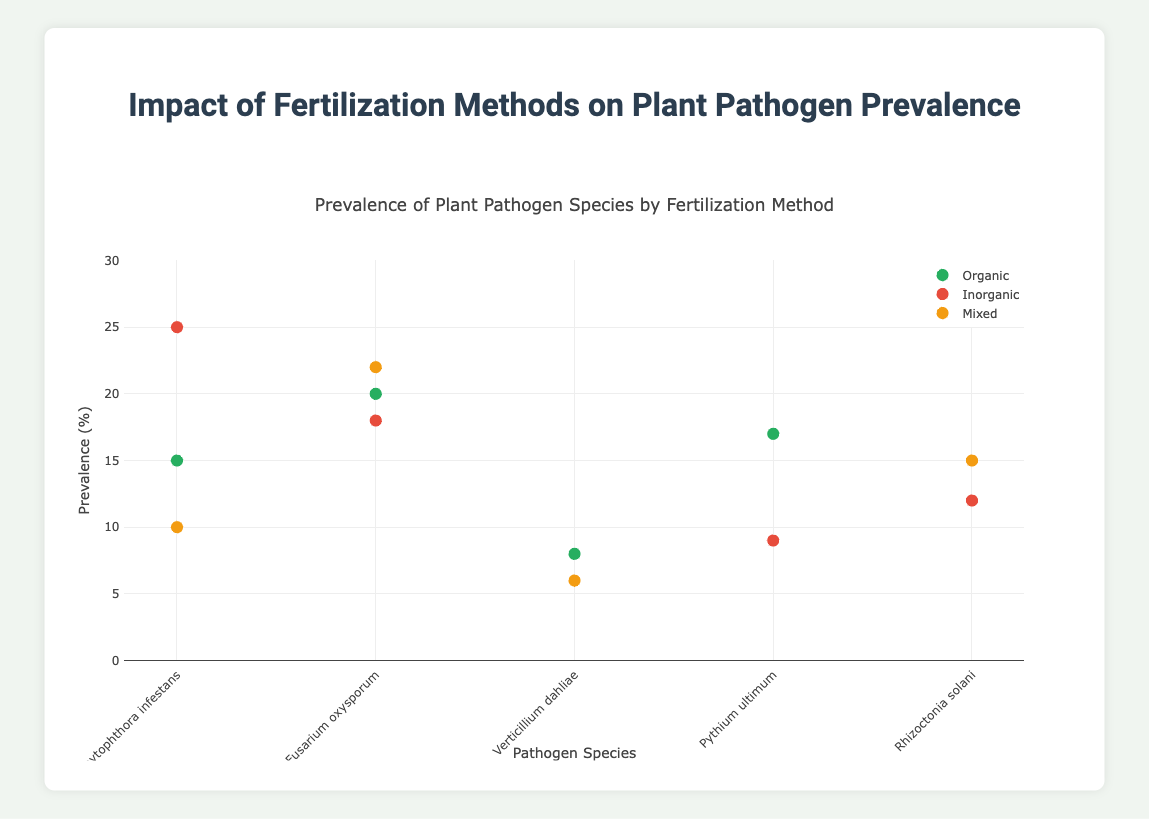What is the title of the plot? The title is located at the top of the plot and reads "Prevalence of Plant Pathogen Species by Fertilization Method"
Answer: Prevalence of Plant Pathogen Species by Fertilization Method How many fertilization methods are compared in this scatter plot? The legend on the right side of the plot shows three distinct color-coded categories representing different fertilization methods: Organic (green), Inorganic (red), and Mixed (yellow)
Answer: Three Which fertilization method has the highest prevalence for Phytophthora infestans? By looking at the markers corresponding to Phytophthora infestans on the x-axis, the highest prevalence value is associated with the Inorganic method at 25%
Answer: Inorganic What is the prevalence of Pythium ultimum in fields with organic fertilization? Locate the point corresponding to Pythium ultimum on the x-axis and check its y-axis value for the Organic category. The prevalence is 17%
Answer: 17% Which pathogen species has the lowest prevalence in the dataset? Identify the markers with the lowest y-axis values and check their corresponding pathogen species. Verticillium dahliae has a prevalence of 6% in Mixed fertilization fields, which is the lowest
Answer: Verticillium dahliae For which pathogen species do different fertilization methods result in the same or similar prevalence values? Compare the y-values for each pathogen species across different fertilization methods. Rhizoctonia solani has similar prevalence values (12% in Inorganic, 15% in Mixed)
Answer: Rhizoctonia solani Which fertilization method shows the greatest variation in pathogen prevalence? By observing the spread of data points for each fertilization method, Inorganic has points ranging from 9% to 25%, which is the widest range
Answer: Inorganic If you average the prevalence of Fusarium oxysporum across all fertilization methods, what is the value? Calculate the average by adding the prevalence percentages for Fusarium oxysporum (Organic: 20%, Inorganic: 18%, Mixed: 22%) and then divide by 3. Thus, (20 + 18 + 22)/3 = 20%
Answer: 20% Which field (A, B, C, or D) has the highest pathogen prevalence recorded in the dataset? Look at the locations and their corresponding y-values for pathogen prevalence. Field A has the highest value at 25% for Phytophthora infestans in Inorganic fertilization
Answer: Field A How does the prevalence of Verticillium dahliae compare between Organic and Mixed fertilization? Check the markers for Verticillium dahliae in both Organic (8%) and Mixed (6%) methods. The prevalence is higher in Organic
Answer: Higher in Organic 